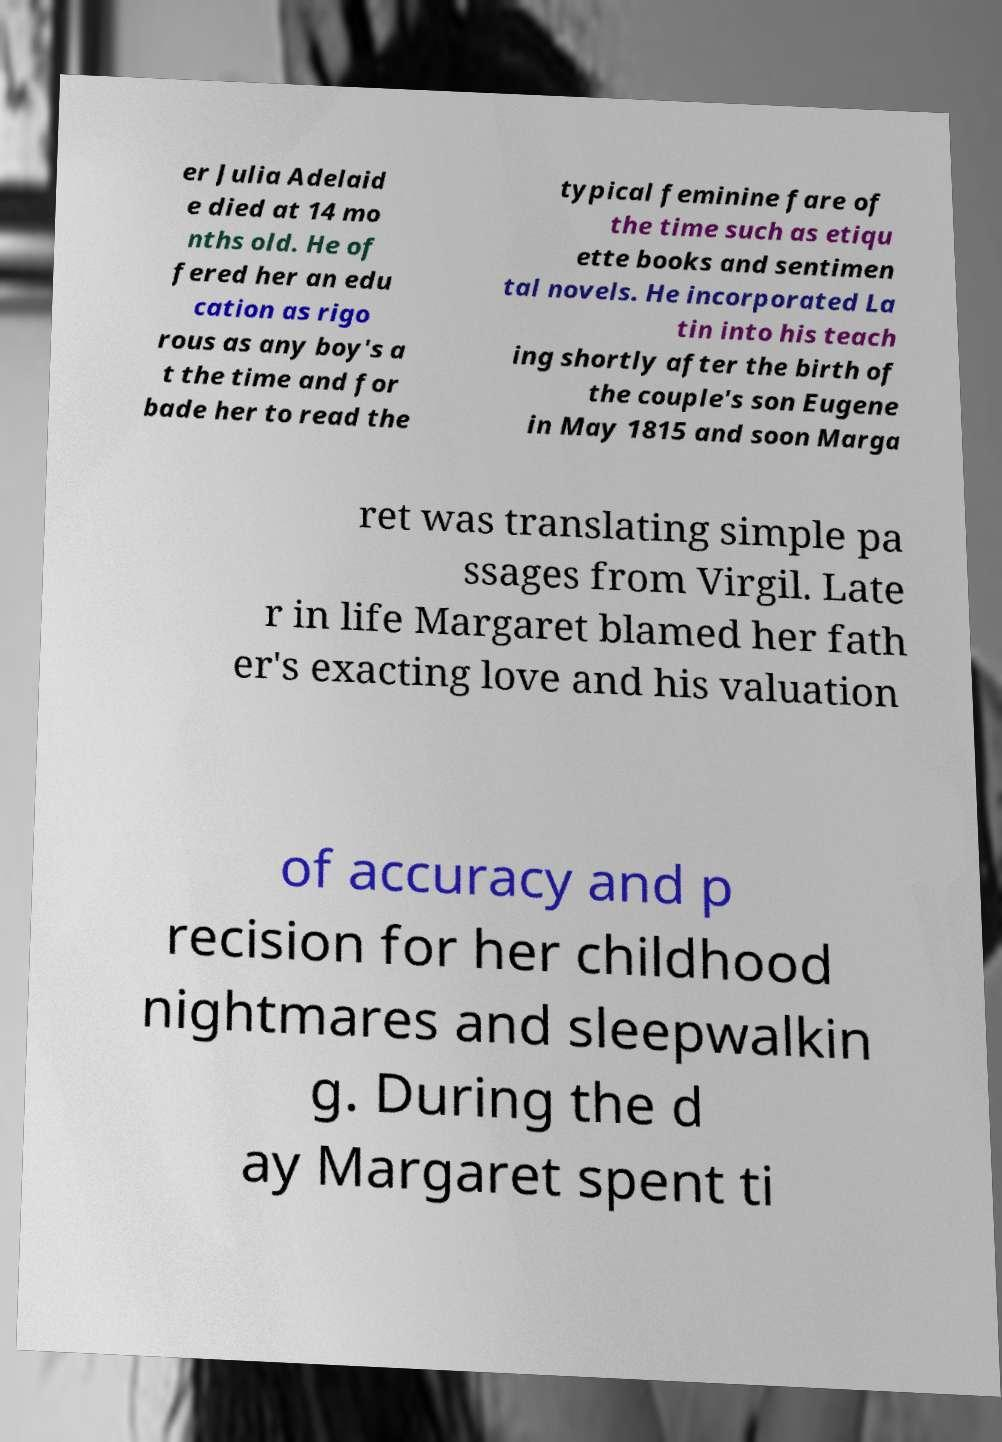Can you read and provide the text displayed in the image?This photo seems to have some interesting text. Can you extract and type it out for me? er Julia Adelaid e died at 14 mo nths old. He of fered her an edu cation as rigo rous as any boy's a t the time and for bade her to read the typical feminine fare of the time such as etiqu ette books and sentimen tal novels. He incorporated La tin into his teach ing shortly after the birth of the couple's son Eugene in May 1815 and soon Marga ret was translating simple pa ssages from Virgil. Late r in life Margaret blamed her fath er's exacting love and his valuation of accuracy and p recision for her childhood nightmares and sleepwalkin g. During the d ay Margaret spent ti 